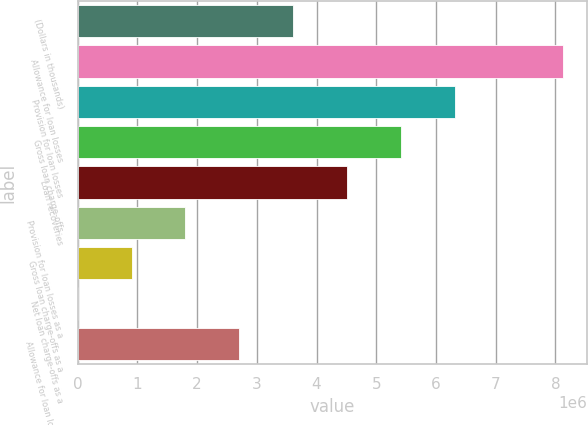<chart> <loc_0><loc_0><loc_500><loc_500><bar_chart><fcel>(Dollars in thousands)<fcel>Allowance for loan losses<fcel>Provision for loan losses<fcel>Gross loan charge-offs<fcel>Loan recoveries<fcel>Provision for loan losses as a<fcel>Gross loan charge-offs as a<fcel>Net loan charge-offs as a<fcel>Allowance for loan losses as a<nl><fcel>3.6097e+06<fcel>8.12182e+06<fcel>6.31697e+06<fcel>5.41455e+06<fcel>4.51212e+06<fcel>1.80485e+06<fcel>902425<fcel>0.31<fcel>2.70727e+06<nl></chart> 